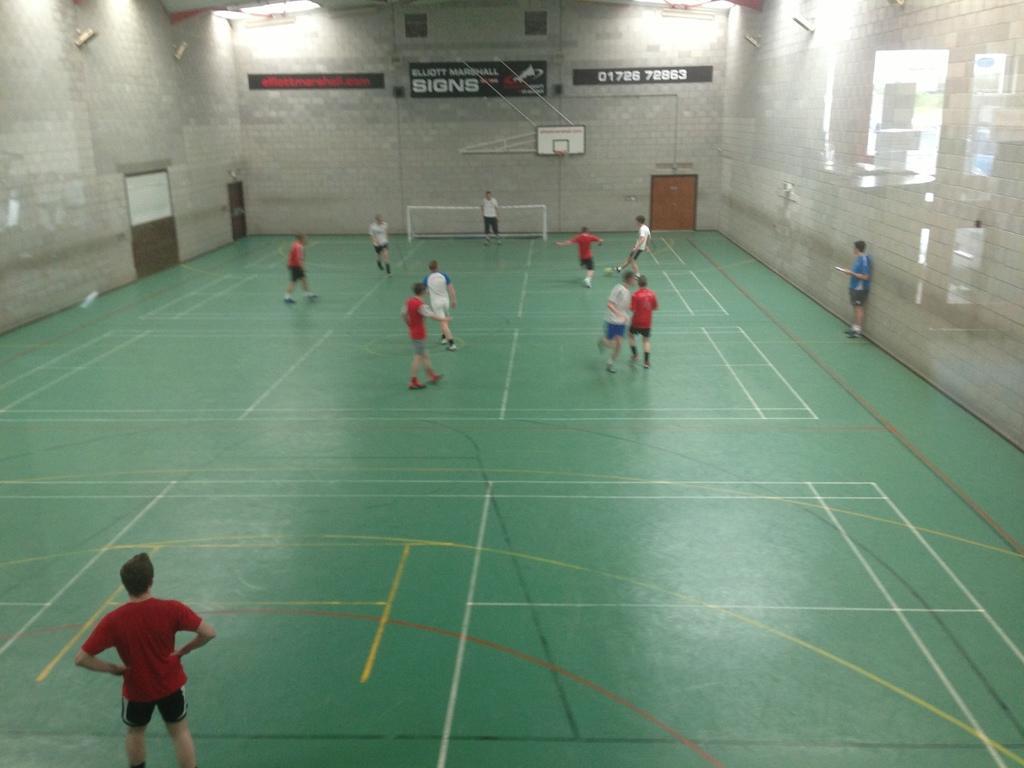Please provide a concise description of this image. These two people are standing and these are players. In the background we can see boards on a wall and net. 